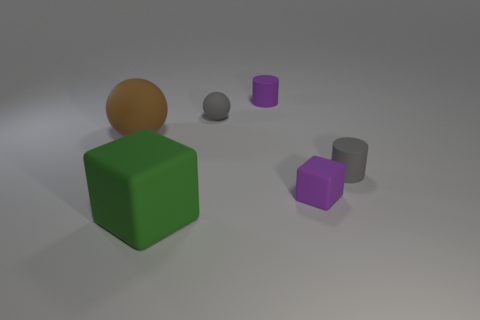There is a object that is in front of the gray rubber cylinder and behind the green thing; what material is it?
Provide a short and direct response. Rubber. Are there more gray matte cylinders than small yellow objects?
Your answer should be compact. Yes. What color is the tiny object that is behind the gray rubber object behind the matte thing that is left of the green object?
Provide a short and direct response. Purple. Is there a matte object that has the same color as the tiny block?
Your answer should be very brief. Yes. Are any large brown rubber cylinders visible?
Offer a terse response. No. There is a cylinder left of the purple rubber block; does it have the same size as the brown ball?
Your answer should be very brief. No. Is the number of purple rubber cylinders less than the number of metal objects?
Make the answer very short. No. There is a big object that is behind the gray matte thing that is to the right of the tiny purple rubber thing that is behind the gray sphere; what is its shape?
Give a very brief answer. Sphere. Is there a red thing that has the same material as the brown object?
Provide a succinct answer. No. There is a matte cube that is to the right of the green object; is its color the same as the tiny rubber cylinder left of the tiny purple matte block?
Your answer should be compact. Yes. 